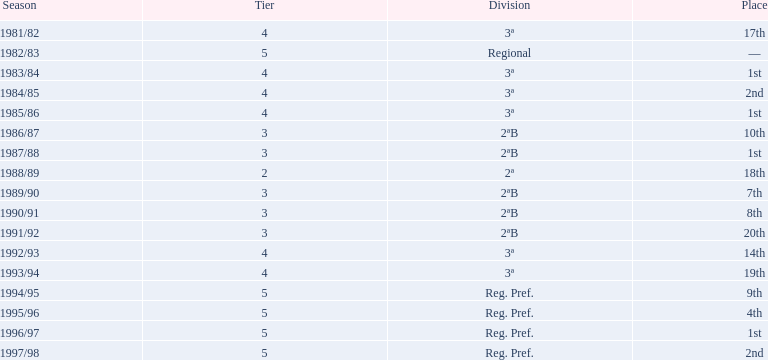How many years did they spend in tier 3? 5. 